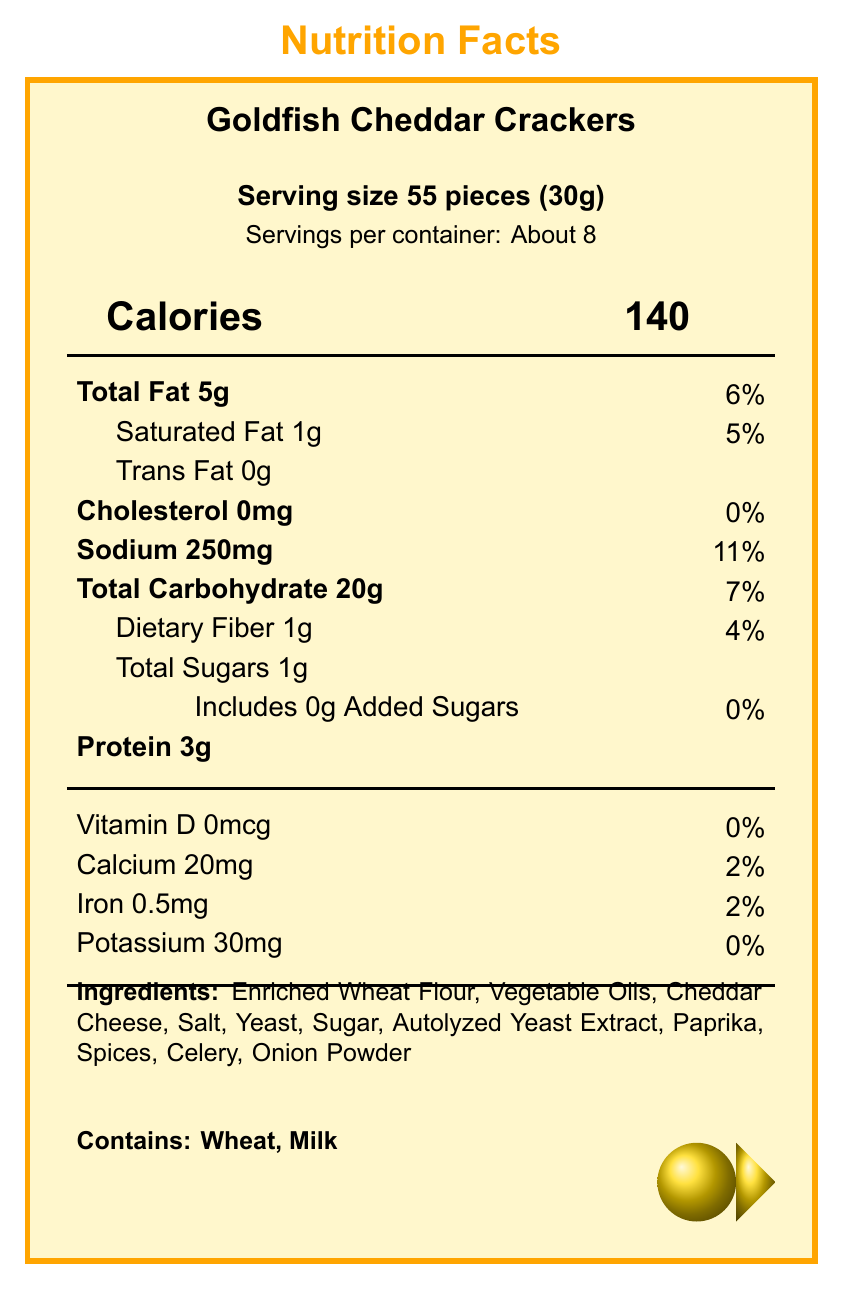what is the serving size for Goldfish Cheddar Crackers? The document specifies the serving size as 55 pieces, which equals 30 grams.
Answer: 55 pieces (30g) how many calories are in one serving? The document lists the calorie content per serving as 140 calories.
Answer: 140 calories how much total sugar is there per serving? The document states that there is a total of 1 gram of sugar per serving.
Answer: 1g how much added sugar does one serving contain? The document indicates that there is no added sugar in a serving (0 grams).
Answer: 0g what is the sodium content per serving? According to the document, one serving contains 250 milligrams of sodium.
Answer: 250mg how many servings are there in a container? The document mentions that there are approximately 8 servings per container.
Answer: About 8 how much protein is in each serving? The document shows that a serving contains 3 grams of protein.
Answer: 3g which ingredient is listed first? Ingredients are typically listed in descending order by weight, and Enriched Wheat Flour is the first ingredient.
Answer: Enriched Wheat Flour does this product contain milk? The allergen section lists milk as one of the allergens contained in the product.
Answer: Yes are there any trans fats in this product? The document specifies that there are 0 grams of trans fat per serving.
Answer: No what percentage of the daily value is the saturated fat content? The document indicates that the saturated fat content is 1 gram per serving, which is 5% of the daily value.
Answer: 5% which of the following is a key nutrient that this snack provides to children? A. Vitamin C B. Protein C. Fiber D. Iron According to the document, one serving contains 3 grams of protein, which helps keep children fuller longer.
Answer: B. Protein how much dietary fiber is in each serving? A. 0g B. 1g C. 2g The document states that each serving contains 1 gram of dietary fiber.
Answer: B. 1g is this snack low in added sugars compared to other children's snacks? The document and the notes section indicate that the snack is low in added sugars (0 grams per serving).
Answer: Yes which observable allergen is missing from the list? Eggs are not mentioned in the allergen list, which includes Wheat and Milk.
Answer: eggs what is the calcium content per serving? The document specifies that each serving contains 20 milligrams of calcium.
Answer: 20mg is the daily value of potassium listed in the document? While the potassium content is mentioned (30mg), the daily value percentage is not provided.
Answer: No summarize the primary nutritional characteristics of this children’s snack. This summary covers the main nutritional aspects mentioned in the document, highlighting total and added sugars, and other important nutrients.
Answer: Goldfish Cheddar Crackers are a children's snack with 140 calories per serving, low in sugars (1g total, 0g added), and contain 5g total fat, 3g protein, 250mg sodium, and various vitamins and minerals. It is a low-added sugar snack, convenient for portion control, good for pairing with fruits or vegetables, and safe to store and carry in resealable bags. what ingredient is used for coloring the snack? According to the ingredients list, Paprika is used, likely for coloring.
Answer: Paprika 